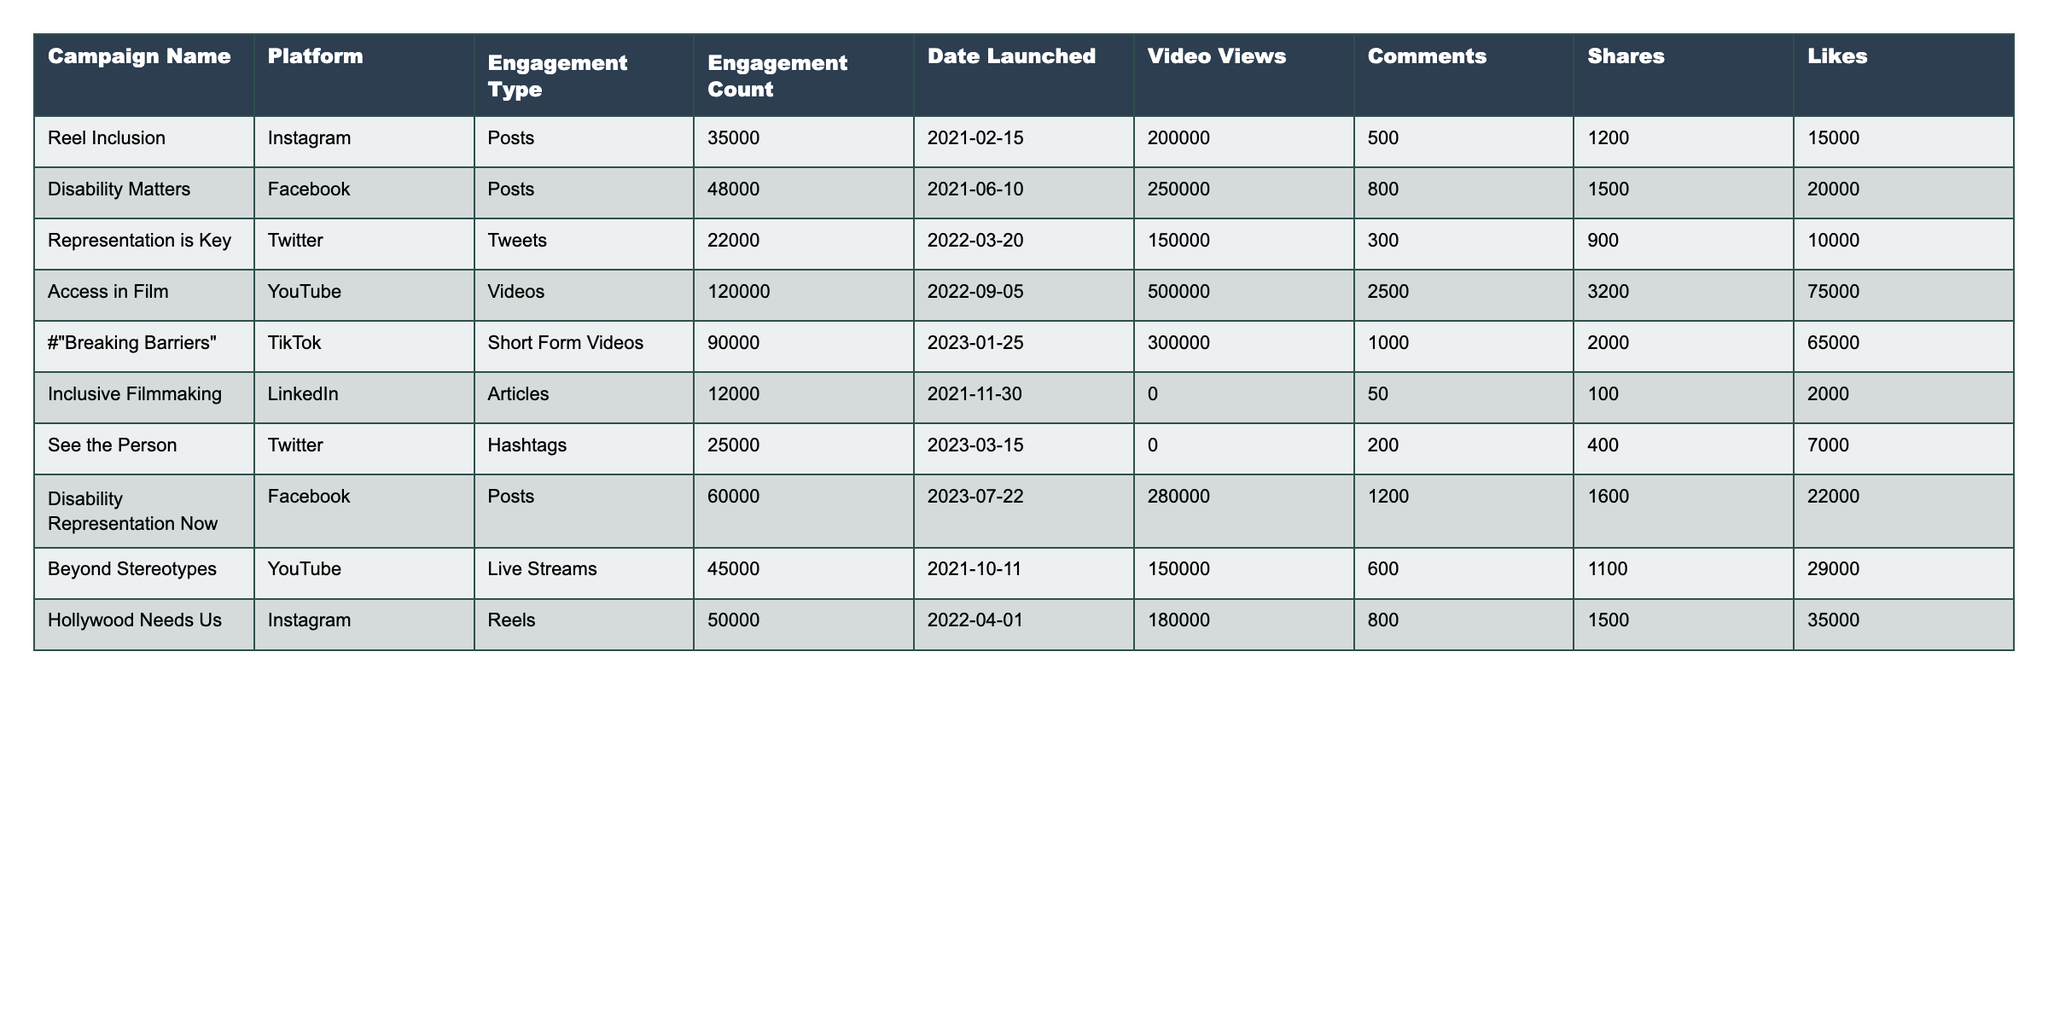What campaign had the highest engagement count? The engagement counts can be compared directly from the 'Engagement Count' column of the table. "Access in Film" has the highest engagement count at 120,000.
Answer: 120000 Which platform had the most posts? By evaluating the 'Engagement Type' column, we see that both Facebook and Instagram have posts, but "Disability Matters" on Facebook has the highest engagement count with 48,000 posts.
Answer: Facebook What is the total number of likes across all campaigns? Summing the 'Likes' column gives us: 15000 + 20000 + 10000 + 75000 + 65000 + 2000 + 7000 + 22000 + 29000 + 35000 = 230,000 total likes.
Answer: 230000 Did "Representation is Key" receive more likes or shares? Checking the 'Likes' (10,000) and 'Shares' (900) for "Representation is Key," it is evident the likes are more than the shares.
Answer: Yes Which campaign on YouTube had the highest video views? From the 'Video Views' column, "Access in Film" has 500,000 views, which is greater than any other YouTube campaign's views.
Answer: Access in Film What is the average engagement count of the campaigns launched in 2023? The campaigns launched in 2023 are "Breaking Barriers," "See the Person," and "Disability Representation Now." Their engagement counts are 90,000, 25,000, and 60,000. Thus, (90000 + 25000 + 60000) / 3 = 65000 is the average engagement count.
Answer: 65000 How many more comments did "Access in Film" receive than "Hollywood Needs Us"? "Access in Film" has 2,500 comments, while "Hollywood Needs Us" has 800. The difference is 2,500 - 800 = 1,700.
Answer: 1700 Which campaign had the least amount of engagement? Looking at the 'Engagement Count' column, "Inclusive Filmmaking" has the least engagement at 12,000.
Answer: 12000 Is there any campaign that had both likes and shares greater than 20,000? From the table, both "Disability Matters" (likes 20,000, shares 1,500) and "Disability Representation Now" (likes 22,000, shares 1,600) fit this condition.
Answer: Yes What percentage of the total comments came from the "Access in Film" campaign? Total comments across all campaigns sum to 8,000. "Access in Film" has 2,500 comments. The percentage is (2500 / 8000) * 100 = 31.25%.
Answer: 31.25% 